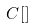<formula> <loc_0><loc_0><loc_500><loc_500>C [ ]</formula> 